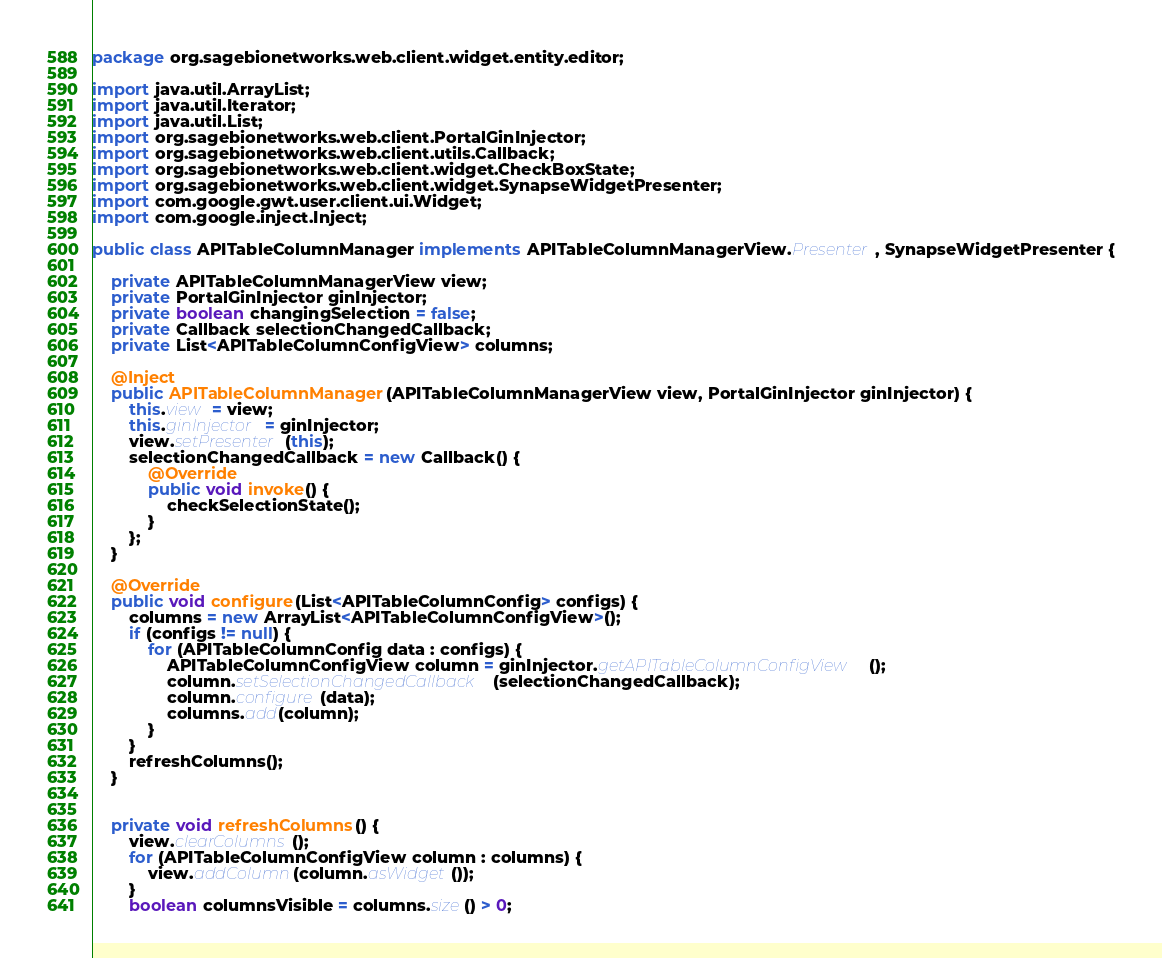Convert code to text. <code><loc_0><loc_0><loc_500><loc_500><_Java_>package org.sagebionetworks.web.client.widget.entity.editor;

import java.util.ArrayList;
import java.util.Iterator;
import java.util.List;
import org.sagebionetworks.web.client.PortalGinInjector;
import org.sagebionetworks.web.client.utils.Callback;
import org.sagebionetworks.web.client.widget.CheckBoxState;
import org.sagebionetworks.web.client.widget.SynapseWidgetPresenter;
import com.google.gwt.user.client.ui.Widget;
import com.google.inject.Inject;

public class APITableColumnManager implements APITableColumnManagerView.Presenter, SynapseWidgetPresenter {

	private APITableColumnManagerView view;
	private PortalGinInjector ginInjector;
	private boolean changingSelection = false;
	private Callback selectionChangedCallback;
	private List<APITableColumnConfigView> columns;

	@Inject
	public APITableColumnManager(APITableColumnManagerView view, PortalGinInjector ginInjector) {
		this.view = view;
		this.ginInjector = ginInjector;
		view.setPresenter(this);
		selectionChangedCallback = new Callback() {
			@Override
			public void invoke() {
				checkSelectionState();
			}
		};
	}

	@Override
	public void configure(List<APITableColumnConfig> configs) {
		columns = new ArrayList<APITableColumnConfigView>();
		if (configs != null) {
			for (APITableColumnConfig data : configs) {
				APITableColumnConfigView column = ginInjector.getAPITableColumnConfigView();
				column.setSelectionChangedCallback(selectionChangedCallback);
				column.configure(data);
				columns.add(column);
			}
		}
		refreshColumns();
	}


	private void refreshColumns() {
		view.clearColumns();
		for (APITableColumnConfigView column : columns) {
			view.addColumn(column.asWidget());
		}
		boolean columnsVisible = columns.size() > 0;</code> 